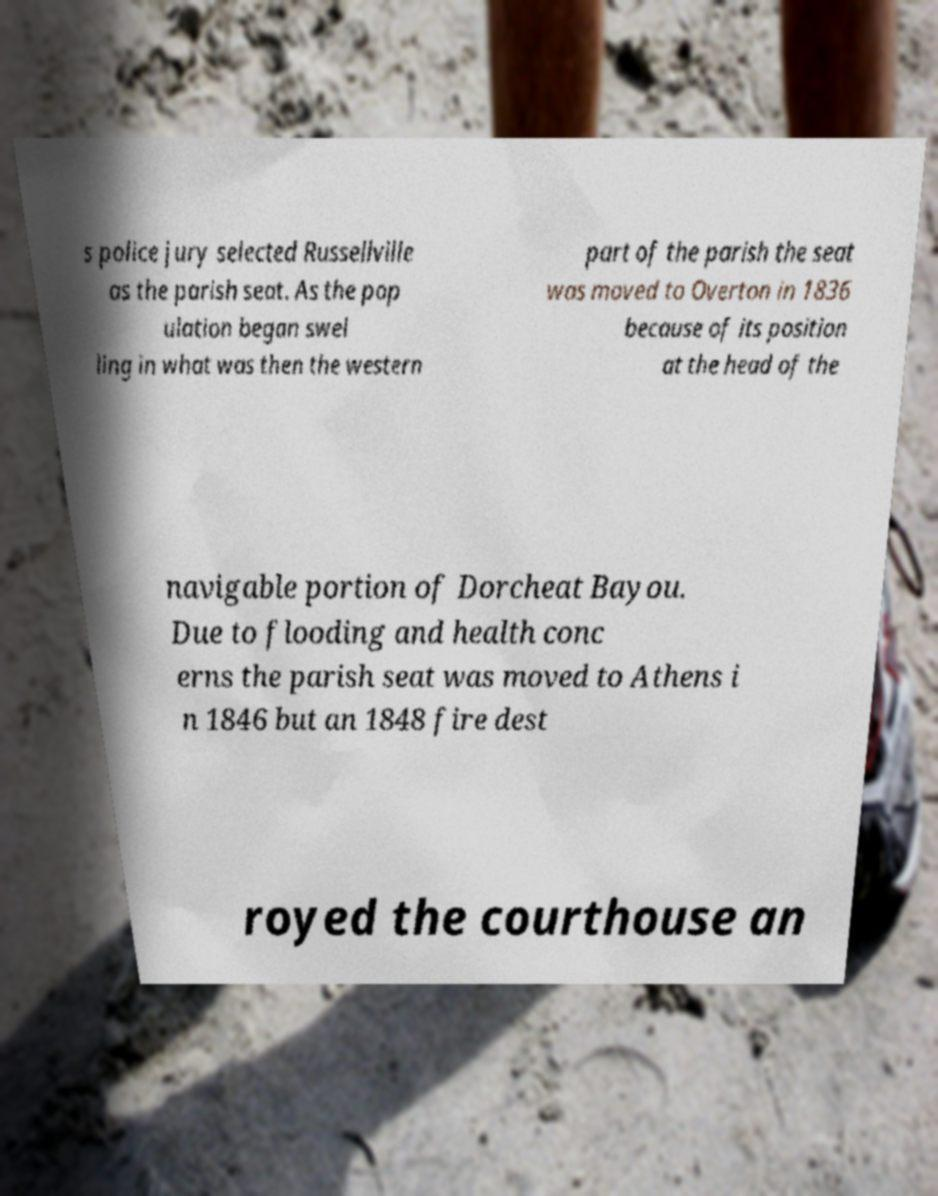For documentation purposes, I need the text within this image transcribed. Could you provide that? s police jury selected Russellville as the parish seat. As the pop ulation began swel ling in what was then the western part of the parish the seat was moved to Overton in 1836 because of its position at the head of the navigable portion of Dorcheat Bayou. Due to flooding and health conc erns the parish seat was moved to Athens i n 1846 but an 1848 fire dest royed the courthouse an 